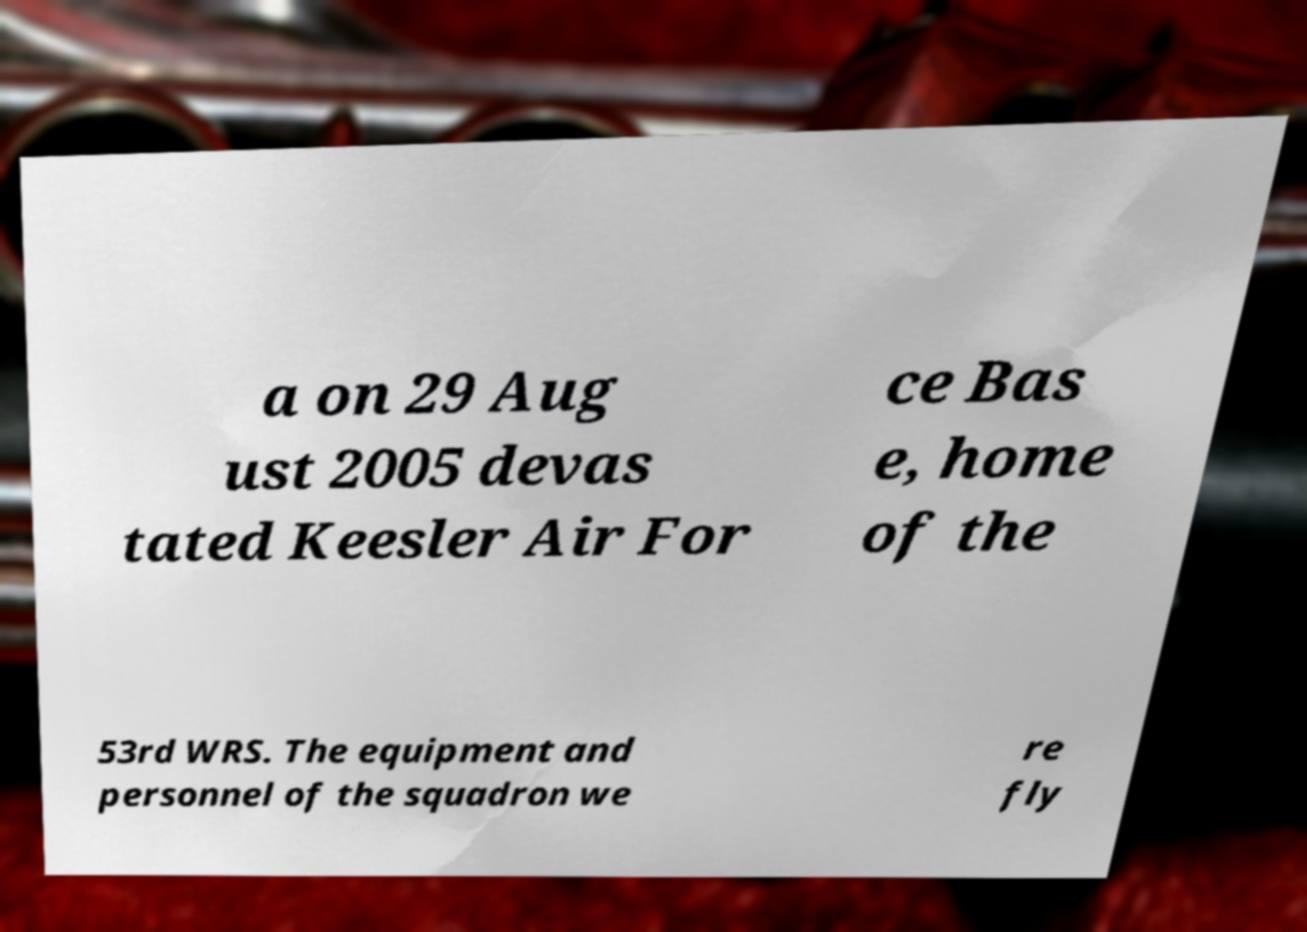Please read and relay the text visible in this image. What does it say? a on 29 Aug ust 2005 devas tated Keesler Air For ce Bas e, home of the 53rd WRS. The equipment and personnel of the squadron we re fly 